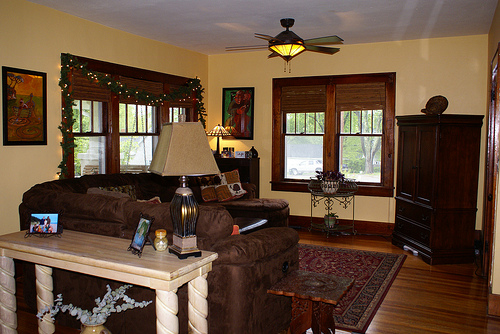Please provide a short description for this region: [0.59, 0.65, 0.81, 0.83]. An elegant Persian-style rug featuring tan, blue, and red patterns on the floor. 